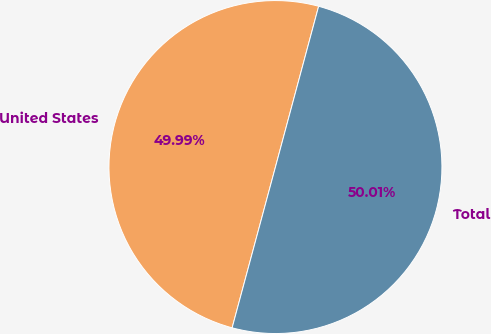Convert chart. <chart><loc_0><loc_0><loc_500><loc_500><pie_chart><fcel>United States<fcel>Total<nl><fcel>49.99%<fcel>50.01%<nl></chart> 